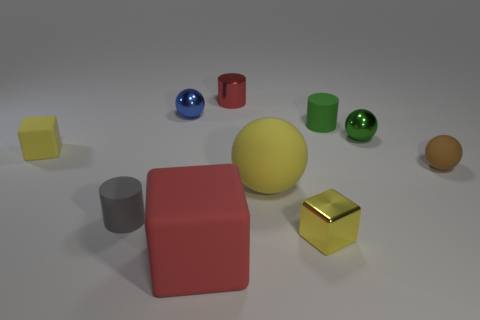Is the number of gray cylinders to the left of the small gray rubber thing less than the number of green matte cylinders?
Keep it short and to the point. Yes. Do the big object that is in front of the small metallic block and the small yellow thing that is on the left side of the small yellow metallic object have the same shape?
Ensure brevity in your answer.  Yes. What number of objects are either yellow rubber objects to the right of the tiny red shiny object or cyan things?
Your response must be concise. 1. What material is the tiny thing that is the same color as the large matte block?
Keep it short and to the point. Metal. Is there a small matte cylinder behind the tiny block that is on the left side of the tiny yellow block that is to the right of the metallic cylinder?
Provide a short and direct response. Yes. Are there fewer small blue metallic objects that are in front of the blue ball than small green rubber cylinders that are in front of the gray matte cylinder?
Your response must be concise. No. What is the color of the cube that is made of the same material as the big red object?
Offer a very short reply. Yellow. What is the color of the matte cylinder that is left of the matte cylinder on the right side of the small red metallic thing?
Provide a short and direct response. Gray. Is there a shiny cylinder that has the same color as the large rubber block?
Provide a succinct answer. Yes. There is a green metal thing that is the same size as the brown ball; what shape is it?
Keep it short and to the point. Sphere. 